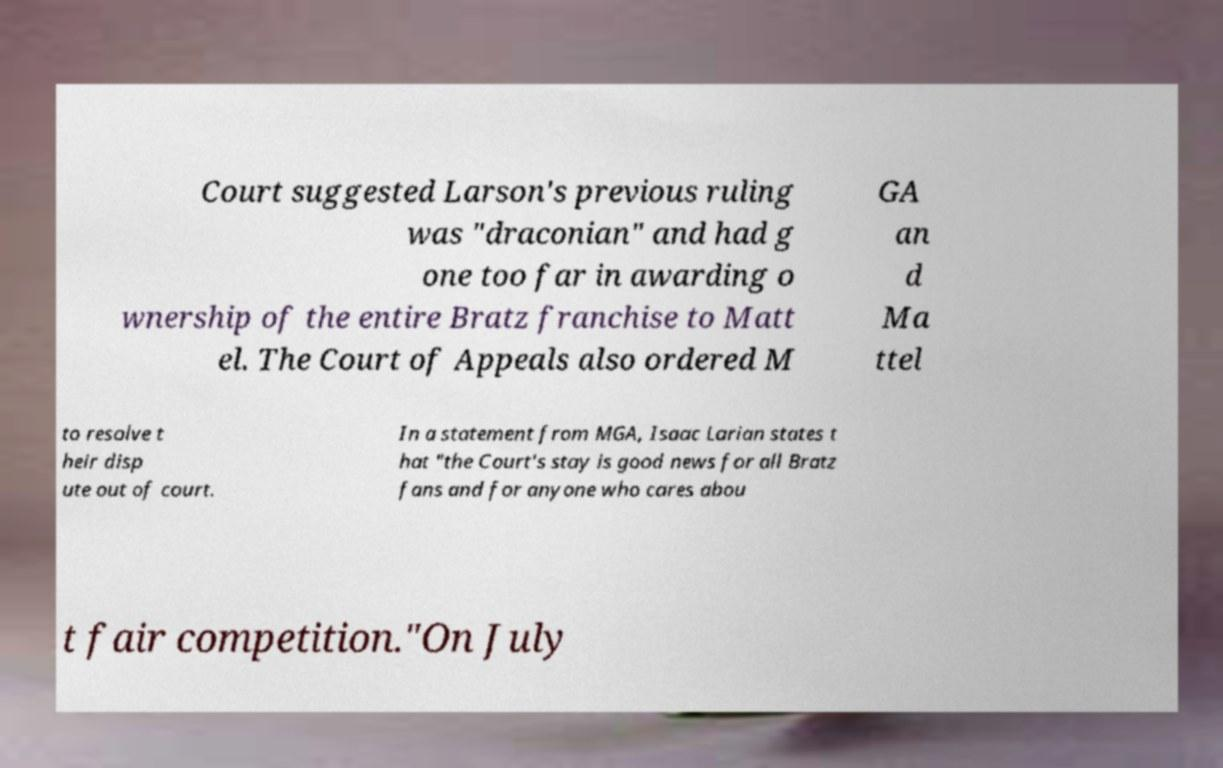I need the written content from this picture converted into text. Can you do that? Court suggested Larson's previous ruling was "draconian" and had g one too far in awarding o wnership of the entire Bratz franchise to Matt el. The Court of Appeals also ordered M GA an d Ma ttel to resolve t heir disp ute out of court. In a statement from MGA, Isaac Larian states t hat "the Court's stay is good news for all Bratz fans and for anyone who cares abou t fair competition."On July 